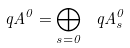<formula> <loc_0><loc_0><loc_500><loc_500>\ q A ^ { 0 } = \bigoplus _ { s = 0 } \ q A ^ { 0 } _ { s }</formula> 